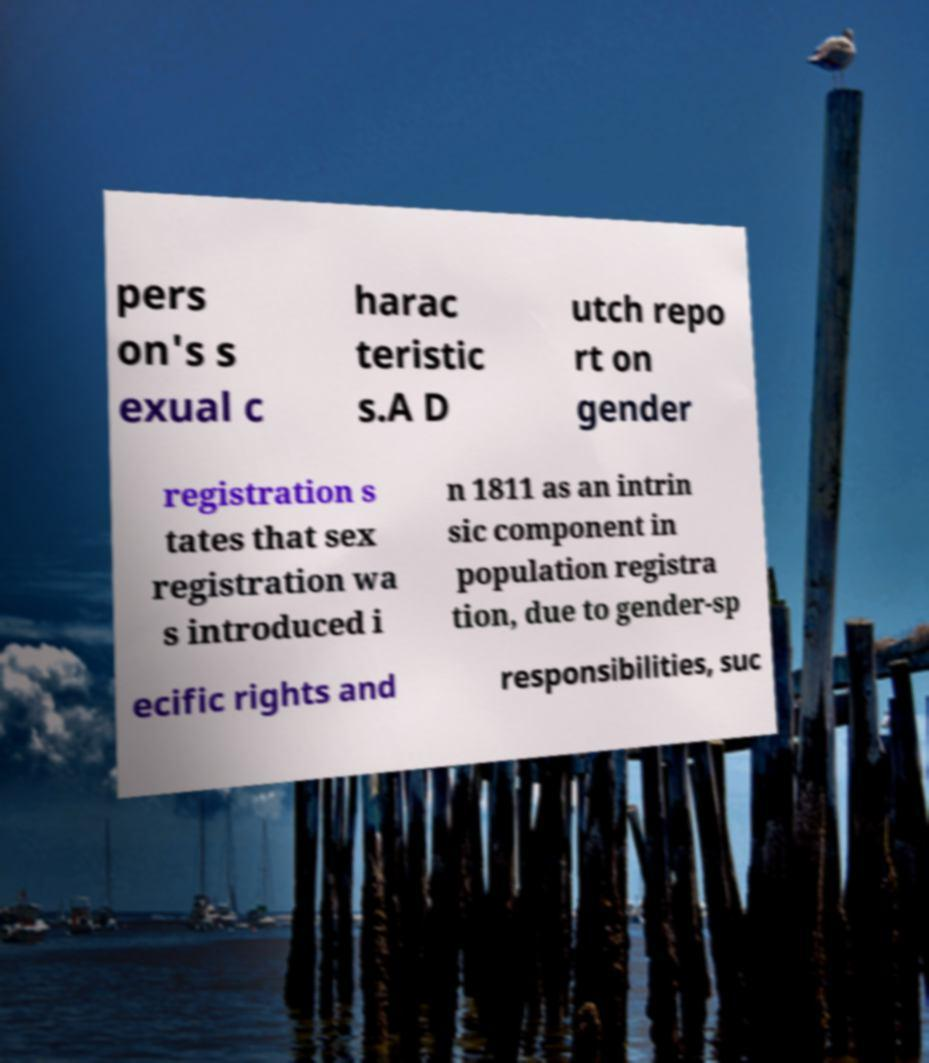For documentation purposes, I need the text within this image transcribed. Could you provide that? pers on's s exual c harac teristic s.A D utch repo rt on gender registration s tates that sex registration wa s introduced i n 1811 as an intrin sic component in population registra tion, due to gender-sp ecific rights and responsibilities, suc 